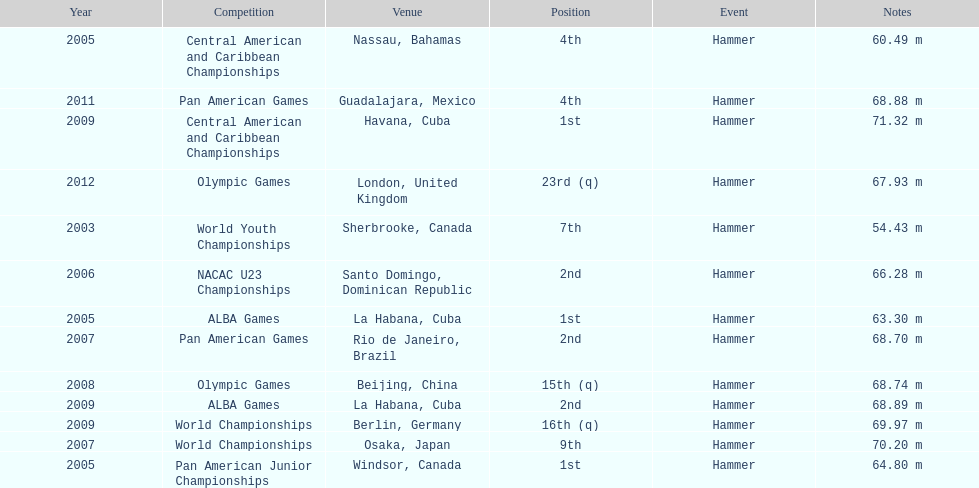In which olympic games did arasay thondike not finish in the top 20? 2012. 